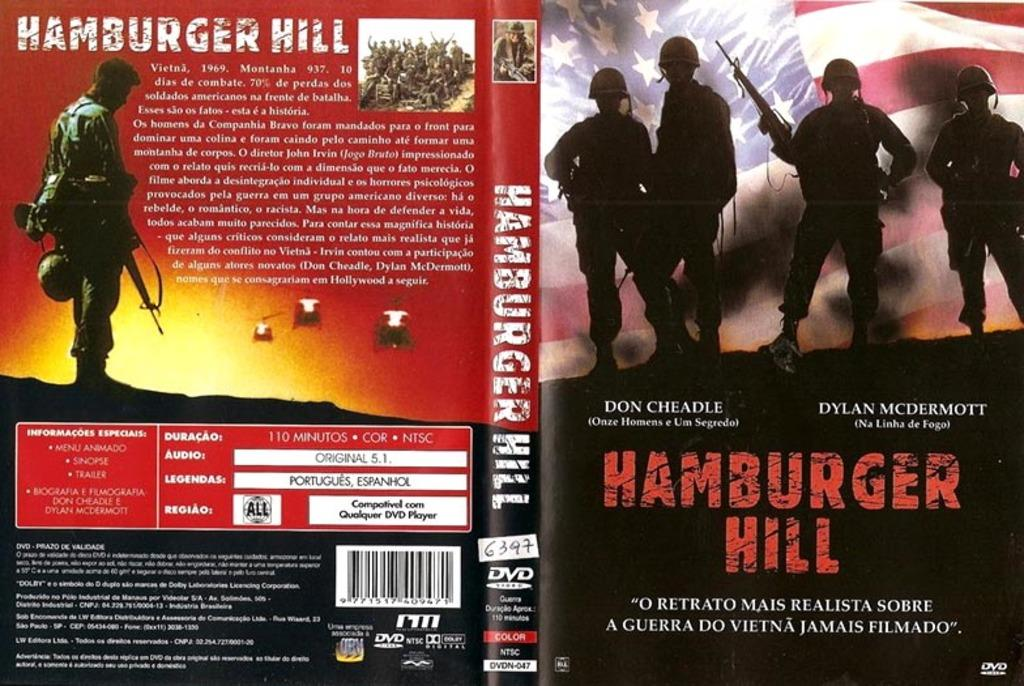<image>
Describe the image concisely. open dvd cover showing front and back of hamburger hill 